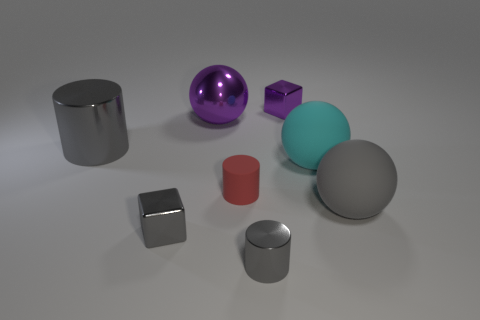How many cylinders are gray objects or small matte objects?
Ensure brevity in your answer.  3. There is a red object that is left of the tiny metallic cylinder; what shape is it?
Give a very brief answer. Cylinder. What color is the small cylinder that is in front of the gray sphere to the right of the small purple metallic block behind the cyan rubber sphere?
Offer a terse response. Gray. Does the cyan ball have the same material as the large gray ball?
Your answer should be compact. Yes. What number of purple things are small metal things or big matte balls?
Offer a terse response. 1. There is a large gray matte ball; what number of red cylinders are to the right of it?
Keep it short and to the point. 0. Is the number of small red matte cylinders greater than the number of rubber blocks?
Your response must be concise. Yes. There is a tiny red rubber object to the left of the small block behind the large cyan rubber object; what is its shape?
Keep it short and to the point. Cylinder. Is the color of the tiny shiny cylinder the same as the big cylinder?
Your answer should be very brief. Yes. Is the number of tiny gray metal cylinders right of the big cyan rubber sphere greater than the number of metallic cylinders?
Your response must be concise. No. 